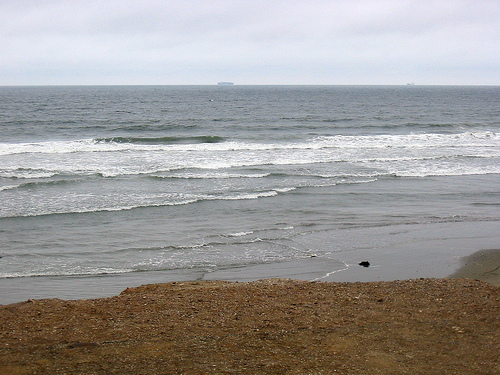<image>
Is the water behind the soil? Yes. From this viewpoint, the water is positioned behind the soil, with the soil partially or fully occluding the water. 